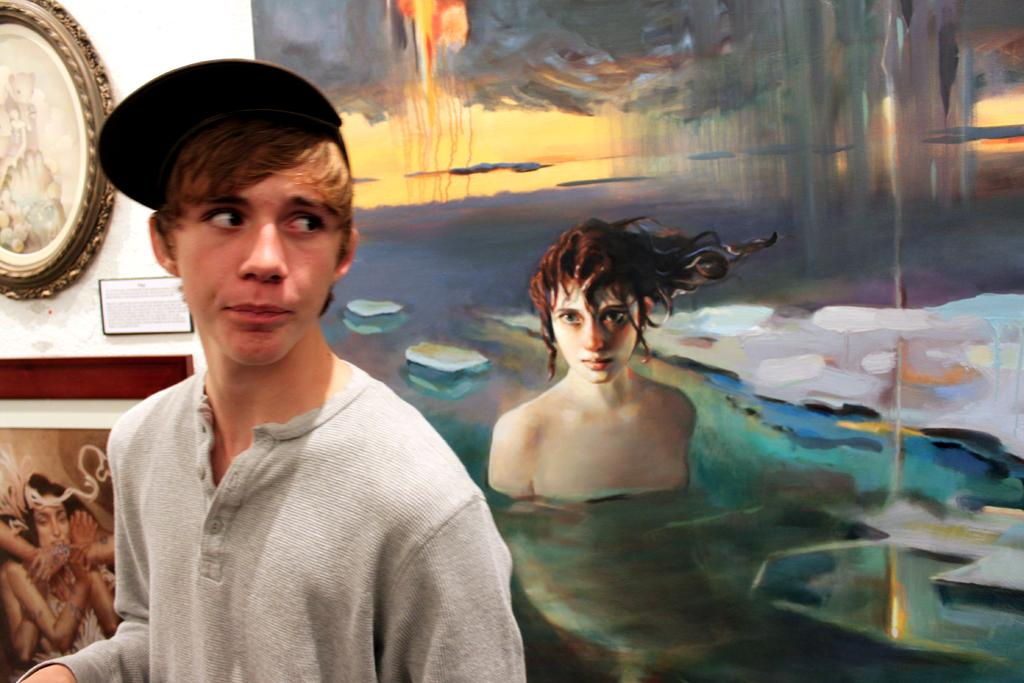Who or what is present in the image? There is a person in the image. What is the person wearing on their head? The person is wearing a cap. What can be seen on the wall behind the person? There are paintings on the wall behind the person. Can you describe the ocean visible in the image? There is no ocean present in the image; it features a person wearing a cap with paintings on the wall behind them. 